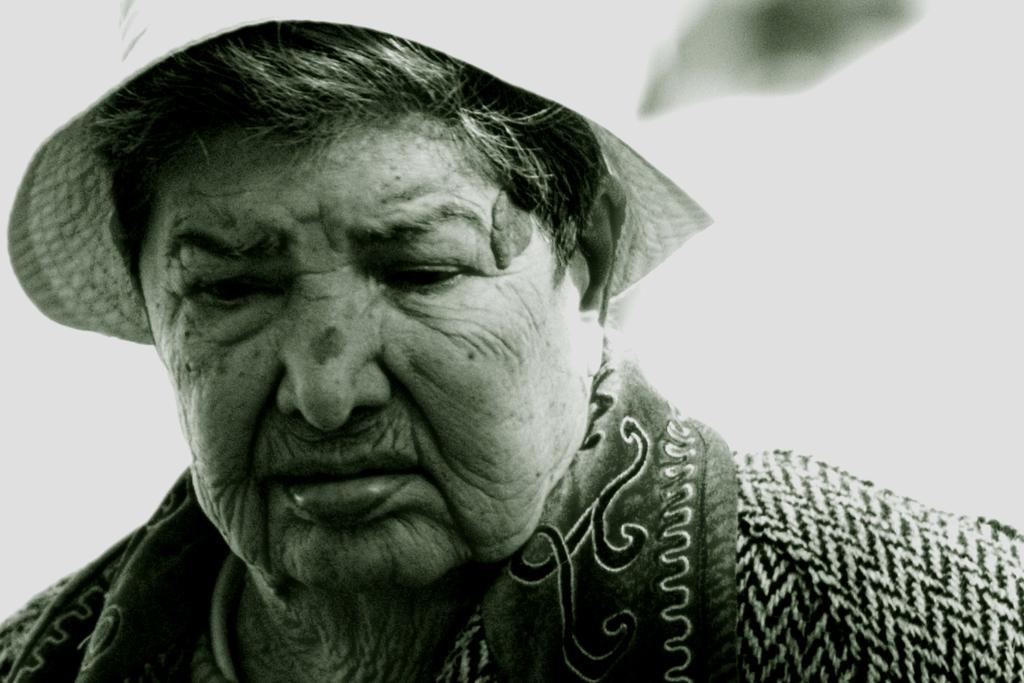What is the color scheme of the image? The image is black and white. Can you describe the person in the image? There is a woman in the image. What is the woman wearing on her head? The woman is wearing a hat. What is the condition of the butter in the image? There is no butter present in the image. 